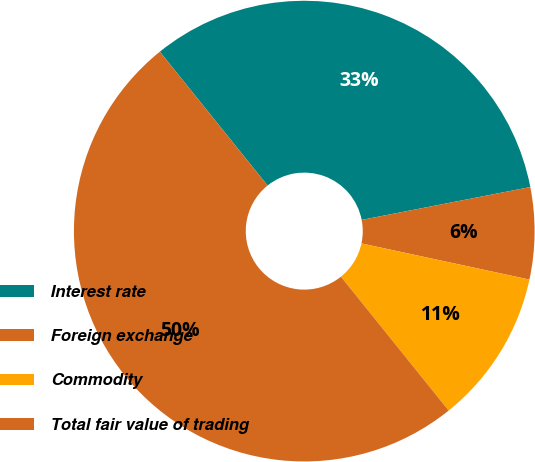Convert chart to OTSL. <chart><loc_0><loc_0><loc_500><loc_500><pie_chart><fcel>Interest rate<fcel>Foreign exchange<fcel>Commodity<fcel>Total fair value of trading<nl><fcel>32.72%<fcel>6.44%<fcel>10.84%<fcel>50.0%<nl></chart> 